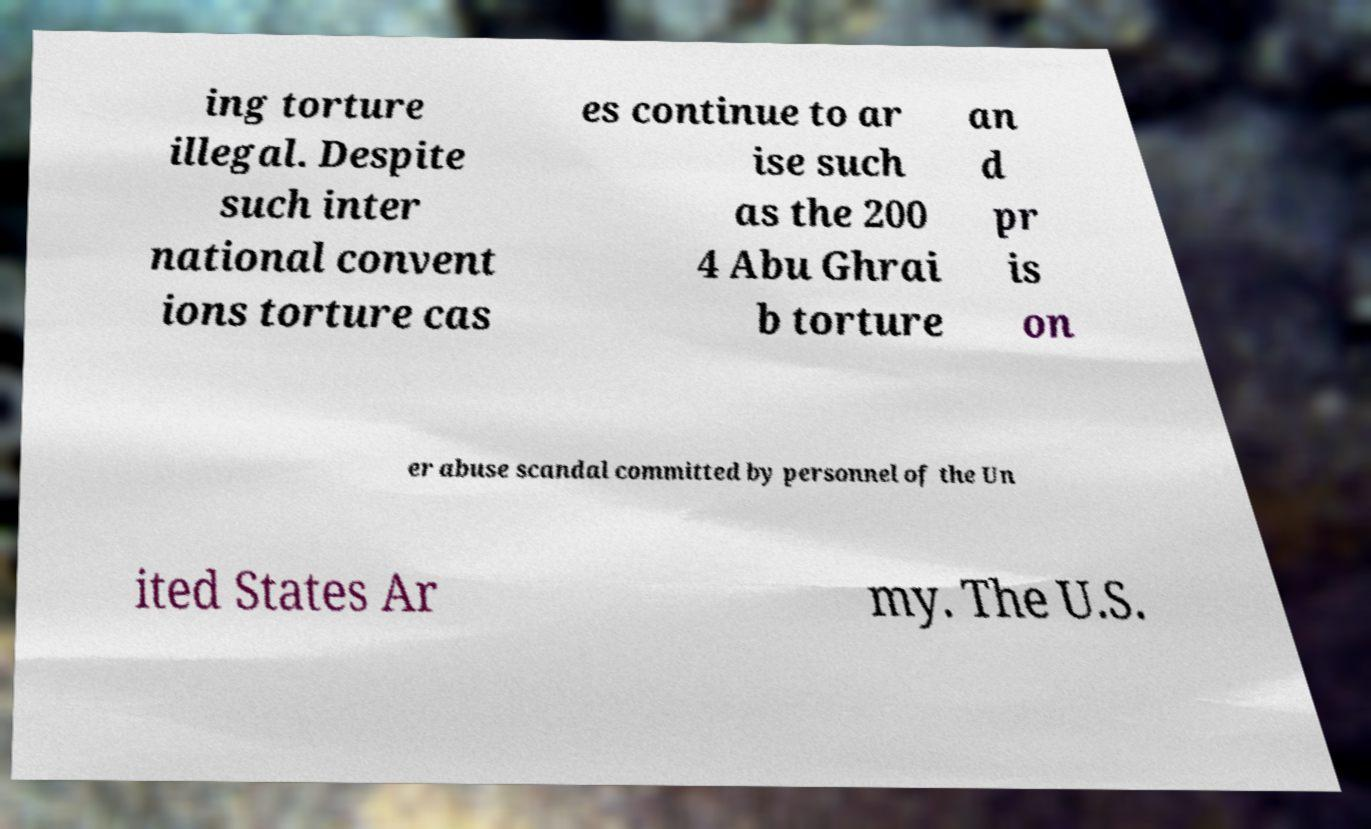Could you extract and type out the text from this image? ing torture illegal. Despite such inter national convent ions torture cas es continue to ar ise such as the 200 4 Abu Ghrai b torture an d pr is on er abuse scandal committed by personnel of the Un ited States Ar my. The U.S. 